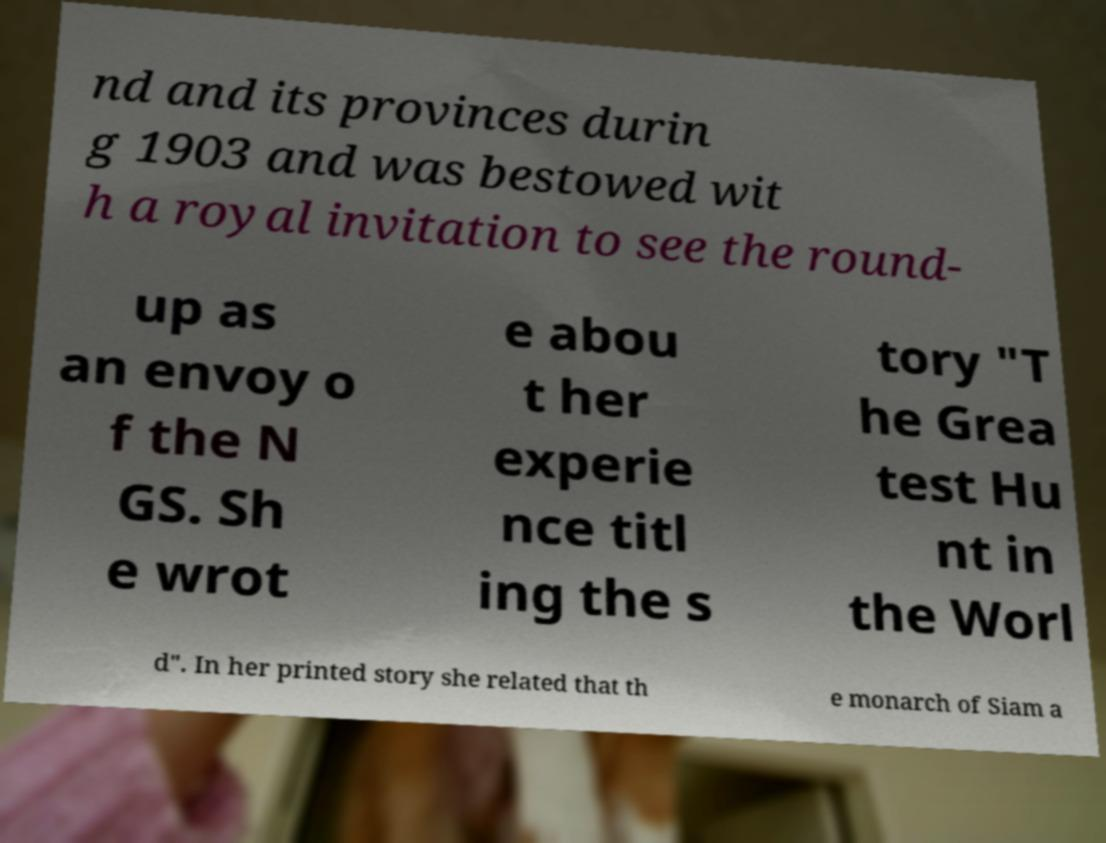Can you read and provide the text displayed in the image?This photo seems to have some interesting text. Can you extract and type it out for me? nd and its provinces durin g 1903 and was bestowed wit h a royal invitation to see the round- up as an envoy o f the N GS. Sh e wrot e abou t her experie nce titl ing the s tory "T he Grea test Hu nt in the Worl d". In her printed story she related that th e monarch of Siam a 